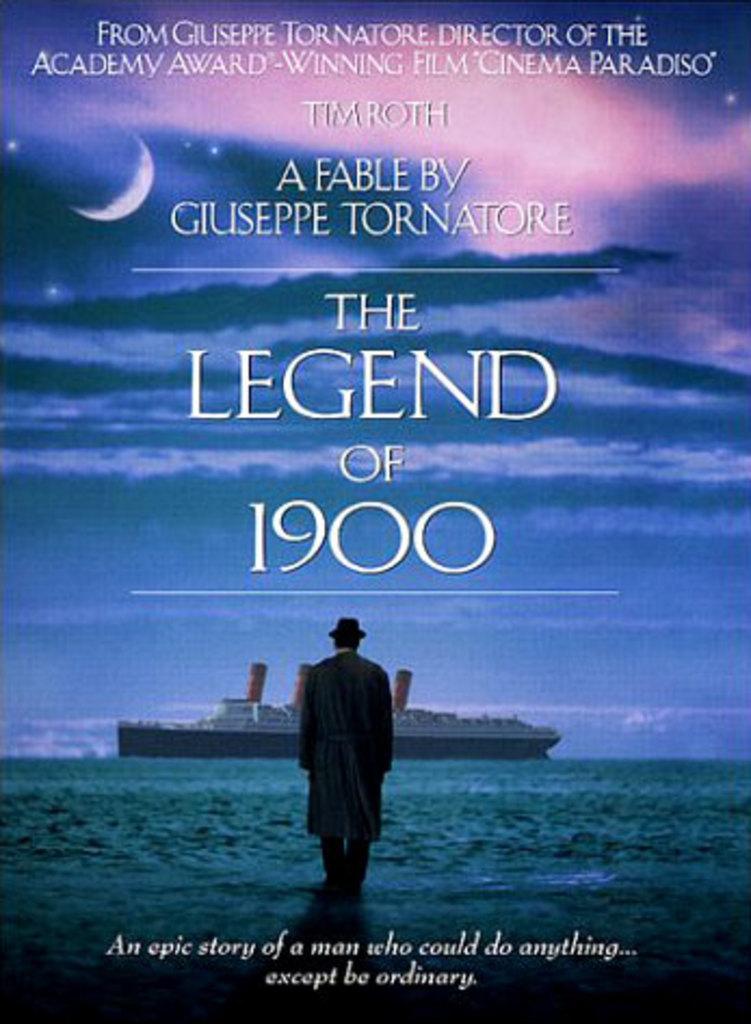Who wrote the legend of 1900?
Offer a very short reply. Giuseppe tornatore. 